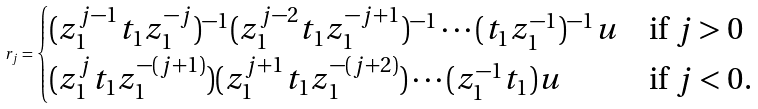Convert formula to latex. <formula><loc_0><loc_0><loc_500><loc_500>r _ { j } = \begin{cases} ( z _ { 1 } ^ { j - 1 } t _ { 1 } z _ { 1 } ^ { - j } ) ^ { - 1 } ( z _ { 1 } ^ { j - 2 } t _ { 1 } z _ { 1 } ^ { - j + 1 } ) ^ { - 1 } \cdots ( t _ { 1 } z _ { 1 } ^ { - 1 } ) ^ { - 1 } u & \text {if $j>0$} \\ ( z _ { 1 } ^ { j } t _ { 1 } z _ { 1 } ^ { - ( j + 1 ) } ) ( z _ { 1 } ^ { j + 1 } t _ { 1 } z _ { 1 } ^ { - ( j + 2 ) } ) \cdots ( z _ { 1 } ^ { - 1 } t _ { 1 } ) u & \text {if $j< 0$.} \end{cases}</formula> 